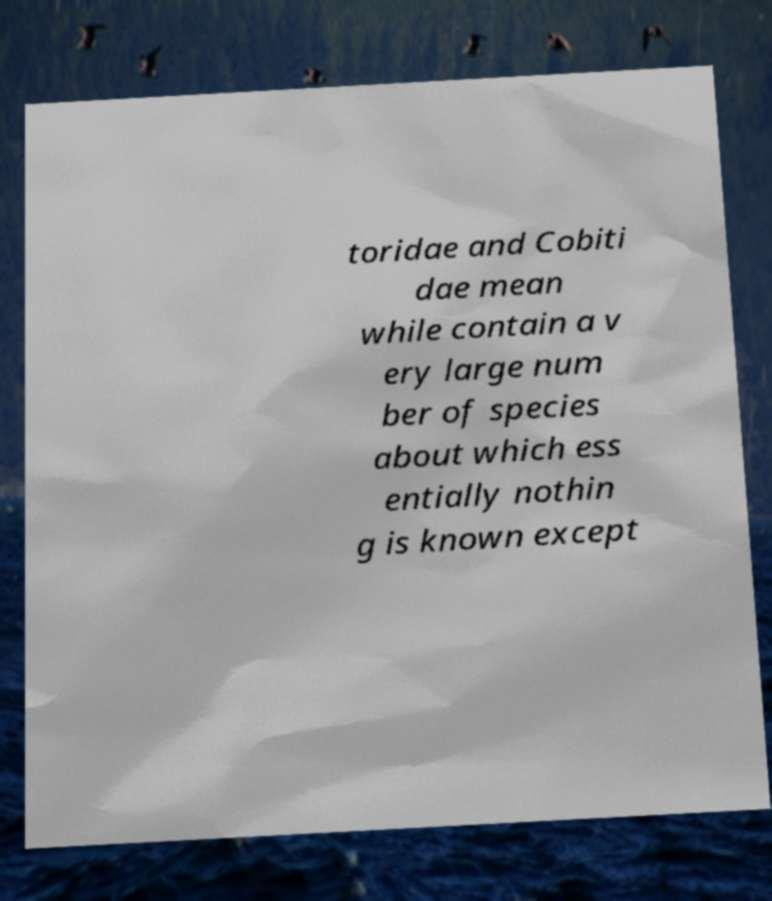Could you extract and type out the text from this image? toridae and Cobiti dae mean while contain a v ery large num ber of species about which ess entially nothin g is known except 